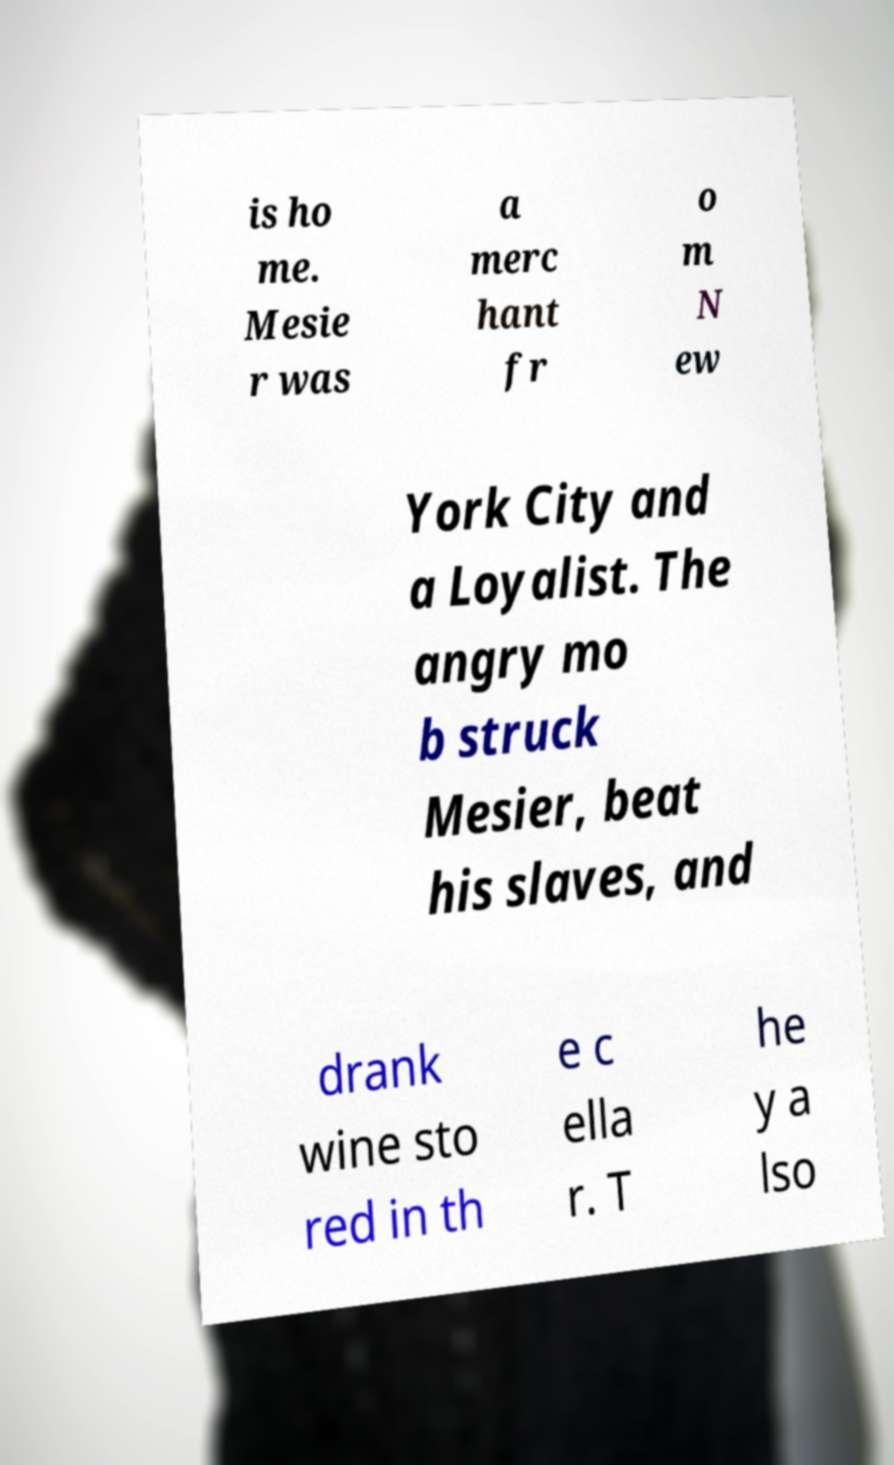There's text embedded in this image that I need extracted. Can you transcribe it verbatim? is ho me. Mesie r was a merc hant fr o m N ew York City and a Loyalist. The angry mo b struck Mesier, beat his slaves, and drank wine sto red in th e c ella r. T he y a lso 